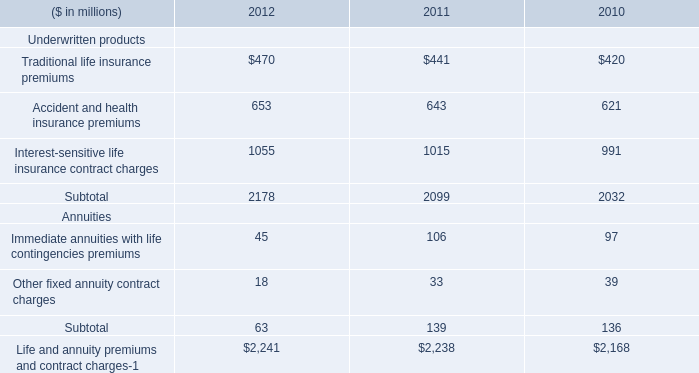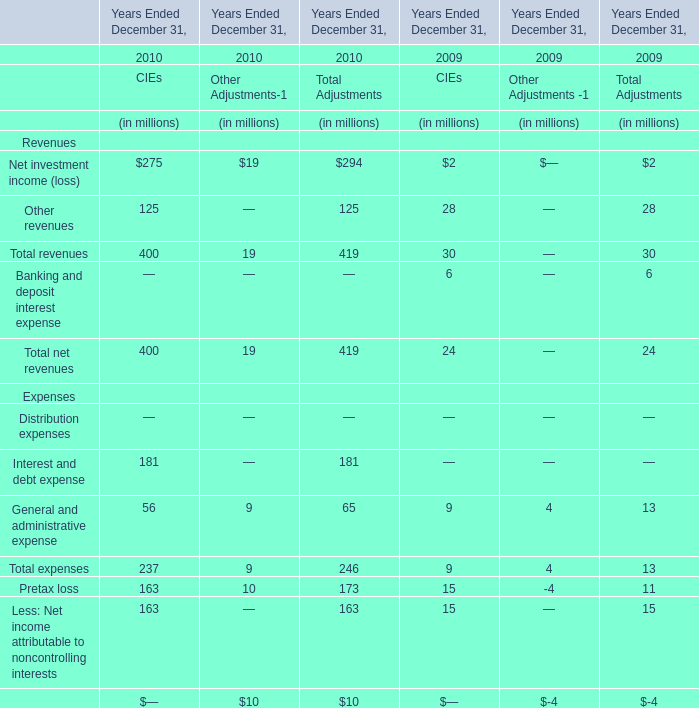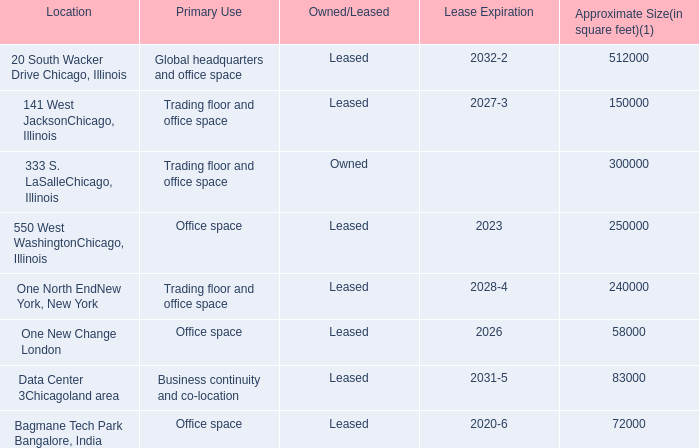What's the current growth rate of Total revenues of CIEs? 
Computations: ((400 - 30) / 30)
Answer: 12.33333. 